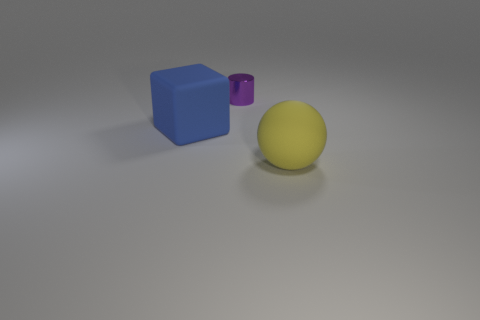Add 1 tiny purple metallic cylinders. How many objects exist? 4 Subtract all blocks. How many objects are left? 2 Subtract 1 purple cylinders. How many objects are left? 2 Subtract all brown blocks. Subtract all green balls. How many blocks are left? 1 Subtract all metallic things. Subtract all red rubber cylinders. How many objects are left? 2 Add 1 blue things. How many blue things are left? 2 Add 1 large yellow matte things. How many large yellow matte things exist? 2 